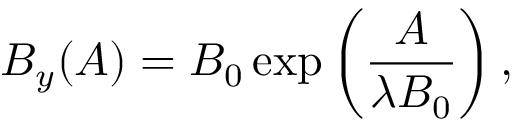<formula> <loc_0><loc_0><loc_500><loc_500>B _ { y } ( A ) = B _ { 0 } \exp \left ( \frac { A } { \lambda B _ { 0 } } \right ) ,</formula> 